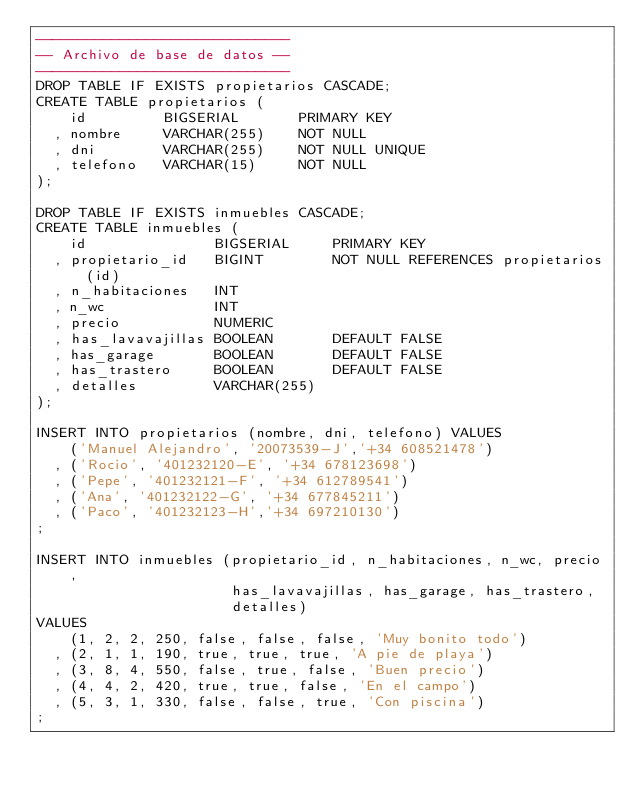<code> <loc_0><loc_0><loc_500><loc_500><_SQL_>------------------------------
-- Archivo de base de datos --
------------------------------
DROP TABLE IF EXISTS propietarios CASCADE;
CREATE TABLE propietarios (
    id         BIGSERIAL       PRIMARY KEY
  , nombre     VARCHAR(255)    NOT NULL
  , dni        VARCHAR(255)    NOT NULL UNIQUE
  , telefono   VARCHAR(15)     NOT NULL
);

DROP TABLE IF EXISTS inmuebles CASCADE;
CREATE TABLE inmuebles (
    id               BIGSERIAL     PRIMARY KEY
  , propietario_id   BIGINT        NOT NULL REFERENCES propietarios(id)
  , n_habitaciones   INT
  , n_wc             INT
  , precio           NUMERIC
  , has_lavavajillas BOOLEAN       DEFAULT FALSE
  , has_garage       BOOLEAN       DEFAULT FALSE
  , has_trastero     BOOLEAN       DEFAULT FALSE
  , detalles         VARCHAR(255)
);

INSERT INTO propietarios (nombre, dni, telefono) VALUES
    ('Manuel Alejandro', '20073539-J','+34 608521478')
  , ('Rocio', '401232120-E', '+34 678123698')
  , ('Pepe', '401232121-F', '+34 612789541')
  , ('Ana', '401232122-G', '+34 677845211')
  , ('Paco', '401232123-H','+34 697210130')
;

INSERT INTO inmuebles (propietario_id, n_habitaciones, n_wc, precio,
                       has_lavavajillas, has_garage, has_trastero,
                       detalles)
VALUES
    (1, 2, 2, 250, false, false, false, 'Muy bonito todo')
  , (2, 1, 1, 190, true, true, true, 'A pie de playa')
  , (3, 8, 4, 550, false, true, false, 'Buen precio')
  , (4, 4, 2, 420, true, true, false, 'En el campo')
  , (5, 3, 1, 330, false, false, true, 'Con piscina')
;
</code> 